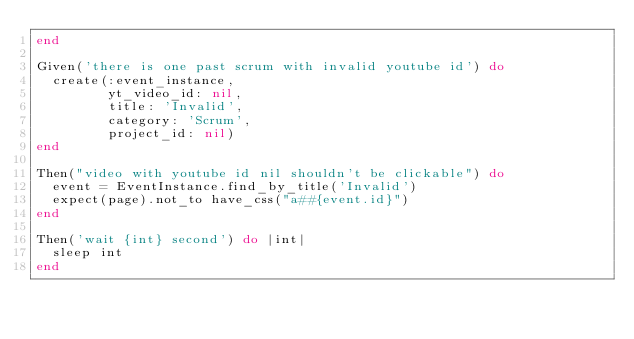<code> <loc_0><loc_0><loc_500><loc_500><_Ruby_>end

Given('there is one past scrum with invalid youtube id') do
  create(:event_instance,
         yt_video_id: nil,
         title: 'Invalid',
         category: 'Scrum',
         project_id: nil)
end

Then("video with youtube id nil shouldn't be clickable") do
  event = EventInstance.find_by_title('Invalid')
  expect(page).not_to have_css("a##{event.id}")
end

Then('wait {int} second') do |int|
  sleep int
end
</code> 